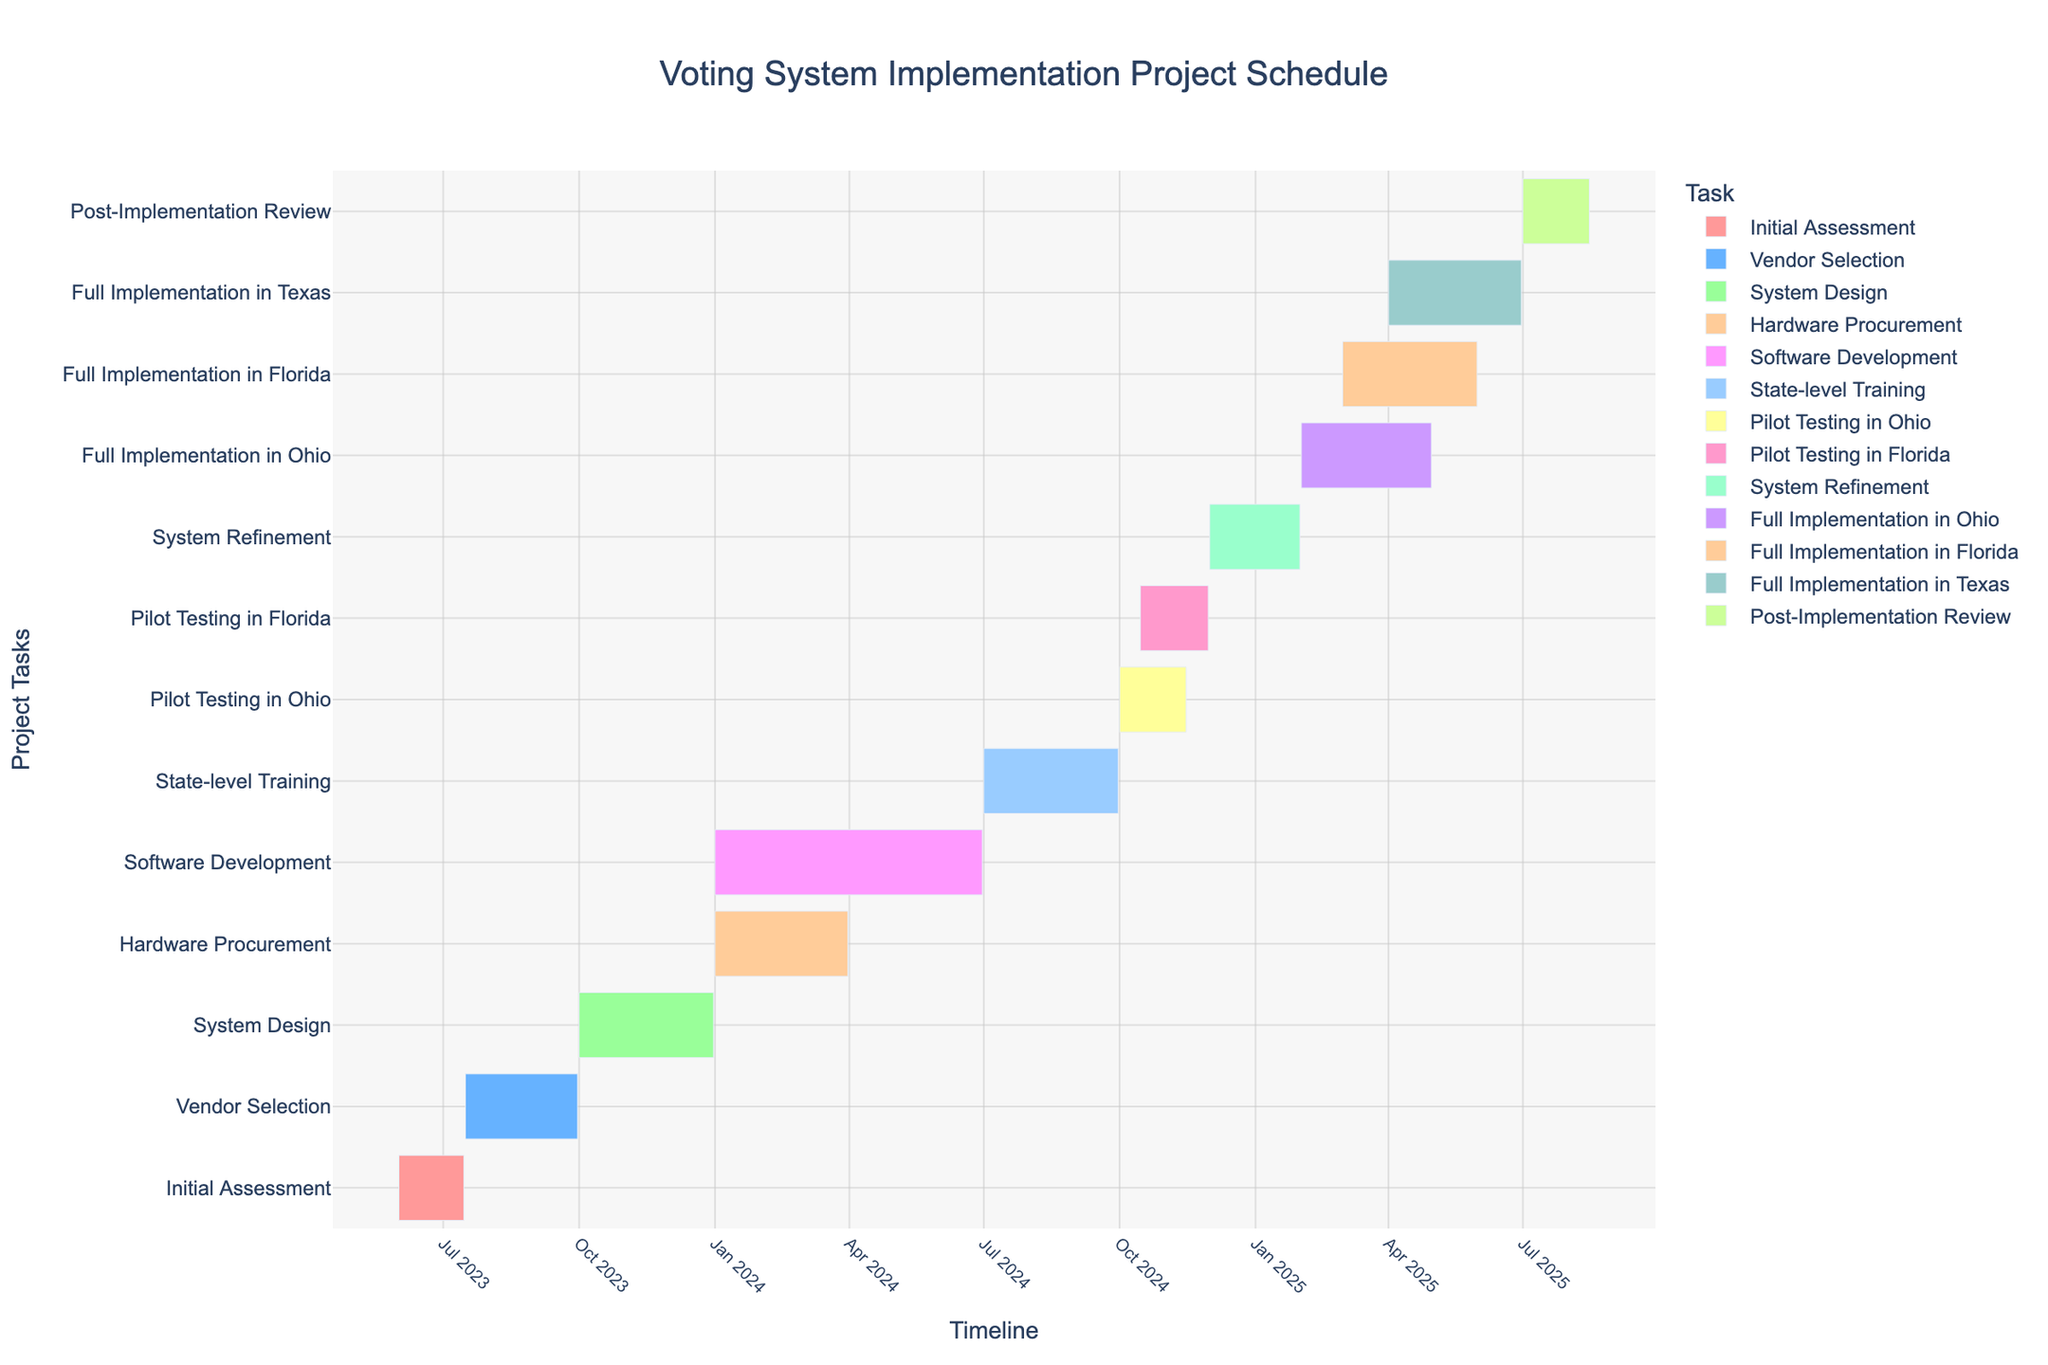What is the title of this Gantt chart? The title is shown at the top of the chart, which provides an overview of what the chart represents.
Answer: Voting System Implementation Project Schedule When does the 'System Design' task start and end? You can see the start and end dates of each task on the x-axis of the chart. The 'System Design' task starts at October 1, 2023, and ends at December 31, 2023.
Answer: October 1, 2023 - December 31, 2023 Which task has the shortest duration? To find the shortest duration, look at the length of each bar in the chart and compare their durations. 'Initial Assessment' has the shortest duration of 45 days.
Answer: Initial Assessment When do the tasks 'Pilot Testing in Ohio' and 'Pilot Testing in Florida' overlap? By visually inspecting the chart, you can see the overlapping period by comparing the bars. These tasks overlap between October 15, 2024, and November 15, 2024.
Answer: October 15, 2024 - November 15, 2024 How many tasks are scheduled to be completed in 2024? Check the end dates of each task to see which ones are within 2024. There are five tasks set to be completed in 2024: 'Hardware Procurement,' 'Software Development,' 'State-level Training,' 'Pilot Testing in Ohio,' and 'Pilot Testing in Florida.'
Answer: 5 Which task spans the longest duration, and how long does it last? Observe the length of each bar and identify the one that is the longest. 'Software Development' has the longest duration, lasting 182 days.
Answer: Software Development, 182 days Are any tasks simultaneously being conducted in multiple states? If so, which ones? Review the tasks and see if any of them occur in different states at the same time. 'Full Implementation' is being conducted in Ohio, Florida, and Texas simultaneously during overlapping periods.
Answer: Full Implementation in Ohio, Full Implementation in Florida, Full Implementation in Texas Compare the durations of 'Vendor Selection' and 'System Refinement.' Which one is longer, and by how many days? 'Vendor Selection' lasts 77 days, and 'System Refinement' lasts 62 days. The difference can be calculated as 77 - 62 = 15 days.
Answer: Vendor Selection, 15 days What are the tasks scheduled to start in January 2024? Look at the start dates in the x-axis for tasks beginning in January 2024. The tasks are 'Hardware Procurement' and 'Software Development.'
Answer: Hardware Procurement, Software Development When does the 'Post-Implementation Review' task end? Find the 'Post-Implementation Review' bar and look at its end date on the x-axis. It ends on August 15, 2025.
Answer: August 15, 2025 